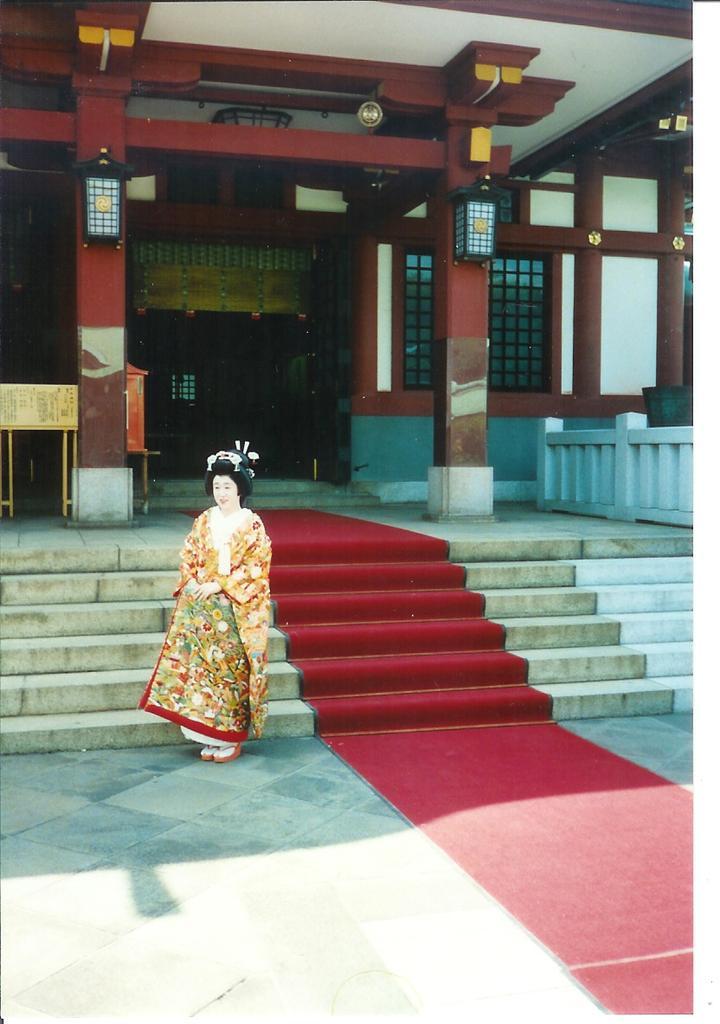Please provide a concise description of this image. In this picture, we see a woman is standing. She is wearing a colorful costume. At the bottom, we see the pavement and a carpet in red color. In the middle, we see the staircase. In the background, we see a building. On the left side, we see a board in yellow color. Beside that, we see a pillar. Behind that, we see an orange color object. On the right side, we see the railing. Beside that, we see a pillar. In the background, we see a wall in white and brown color and we see the windows. At the top, we see the roof of the building. 